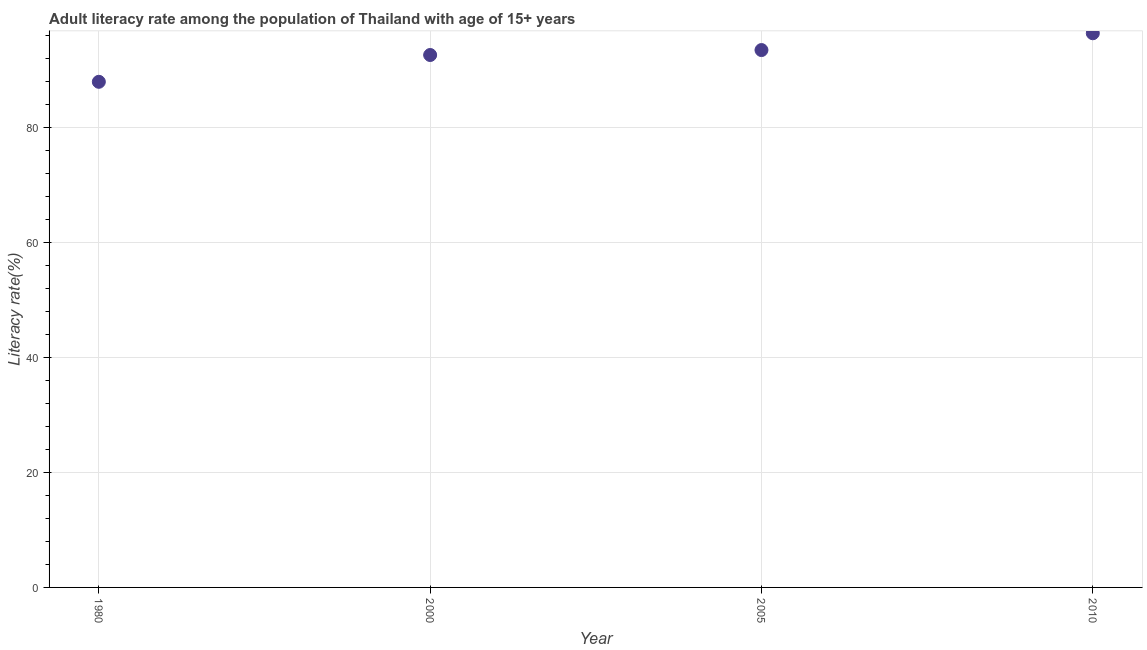What is the adult literacy rate in 2010?
Keep it short and to the point. 96.43. Across all years, what is the maximum adult literacy rate?
Provide a short and direct response. 96.43. Across all years, what is the minimum adult literacy rate?
Offer a terse response. 87.98. In which year was the adult literacy rate maximum?
Make the answer very short. 2010. What is the sum of the adult literacy rate?
Offer a terse response. 370.57. What is the difference between the adult literacy rate in 1980 and 2005?
Offer a very short reply. -5.52. What is the average adult literacy rate per year?
Your answer should be compact. 92.64. What is the median adult literacy rate?
Provide a short and direct response. 93.08. Do a majority of the years between 2000 and 2010 (inclusive) have adult literacy rate greater than 20 %?
Make the answer very short. Yes. What is the ratio of the adult literacy rate in 2005 to that in 2010?
Offer a terse response. 0.97. Is the adult literacy rate in 2005 less than that in 2010?
Provide a short and direct response. Yes. What is the difference between the highest and the second highest adult literacy rate?
Keep it short and to the point. 2.92. Is the sum of the adult literacy rate in 2005 and 2010 greater than the maximum adult literacy rate across all years?
Your answer should be compact. Yes. What is the difference between the highest and the lowest adult literacy rate?
Make the answer very short. 8.45. In how many years, is the adult literacy rate greater than the average adult literacy rate taken over all years?
Your answer should be compact. 3. How many years are there in the graph?
Your answer should be compact. 4. Are the values on the major ticks of Y-axis written in scientific E-notation?
Your answer should be compact. No. Does the graph contain any zero values?
Ensure brevity in your answer.  No. Does the graph contain grids?
Your response must be concise. Yes. What is the title of the graph?
Your answer should be compact. Adult literacy rate among the population of Thailand with age of 15+ years. What is the label or title of the Y-axis?
Provide a succinct answer. Literacy rate(%). What is the Literacy rate(%) in 1980?
Ensure brevity in your answer.  87.98. What is the Literacy rate(%) in 2000?
Provide a short and direct response. 92.65. What is the Literacy rate(%) in 2005?
Offer a very short reply. 93.51. What is the Literacy rate(%) in 2010?
Keep it short and to the point. 96.43. What is the difference between the Literacy rate(%) in 1980 and 2000?
Offer a terse response. -4.66. What is the difference between the Literacy rate(%) in 1980 and 2005?
Offer a very short reply. -5.52. What is the difference between the Literacy rate(%) in 1980 and 2010?
Provide a short and direct response. -8.45. What is the difference between the Literacy rate(%) in 2000 and 2005?
Offer a very short reply. -0.86. What is the difference between the Literacy rate(%) in 2000 and 2010?
Your response must be concise. -3.78. What is the difference between the Literacy rate(%) in 2005 and 2010?
Make the answer very short. -2.92. What is the ratio of the Literacy rate(%) in 1980 to that in 2000?
Your answer should be compact. 0.95. What is the ratio of the Literacy rate(%) in 1980 to that in 2005?
Make the answer very short. 0.94. What is the ratio of the Literacy rate(%) in 1980 to that in 2010?
Offer a very short reply. 0.91. What is the ratio of the Literacy rate(%) in 2000 to that in 2010?
Give a very brief answer. 0.96. What is the ratio of the Literacy rate(%) in 2005 to that in 2010?
Ensure brevity in your answer.  0.97. 